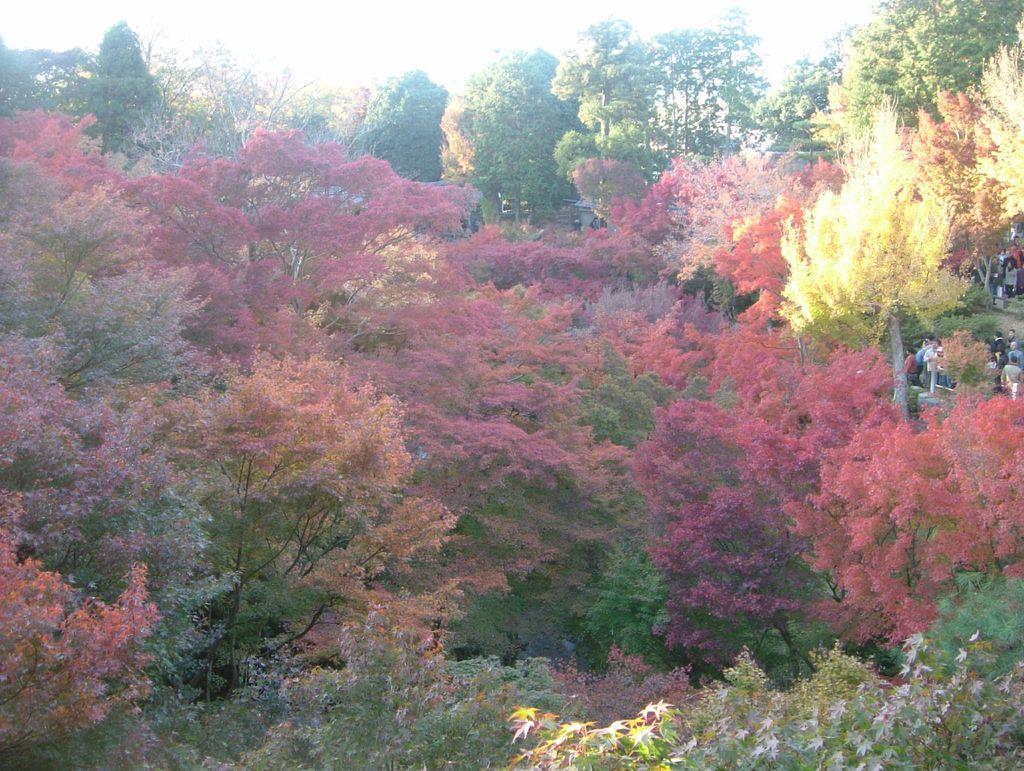Describe this image in one or two sentences. In the foreground of this image, there are trees. At the top, there is the sky and we can also see few people on the right. 